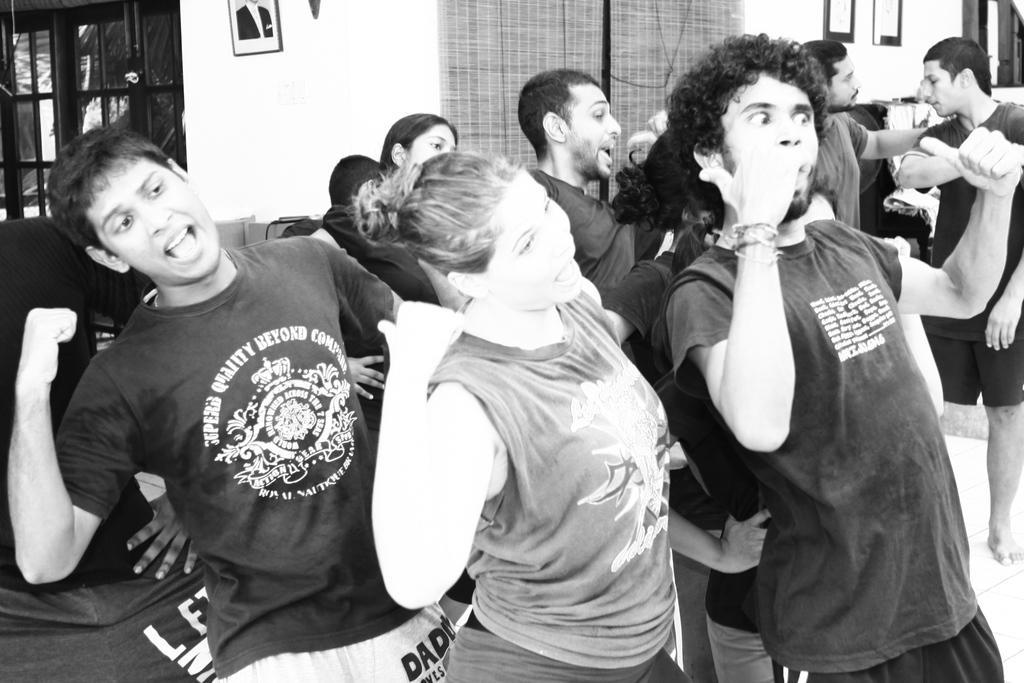How would you summarize this image in a sentence or two? This is a black and white picture, we can see a few people standing and in the background, we can see the windows and photo frames on the wall. 